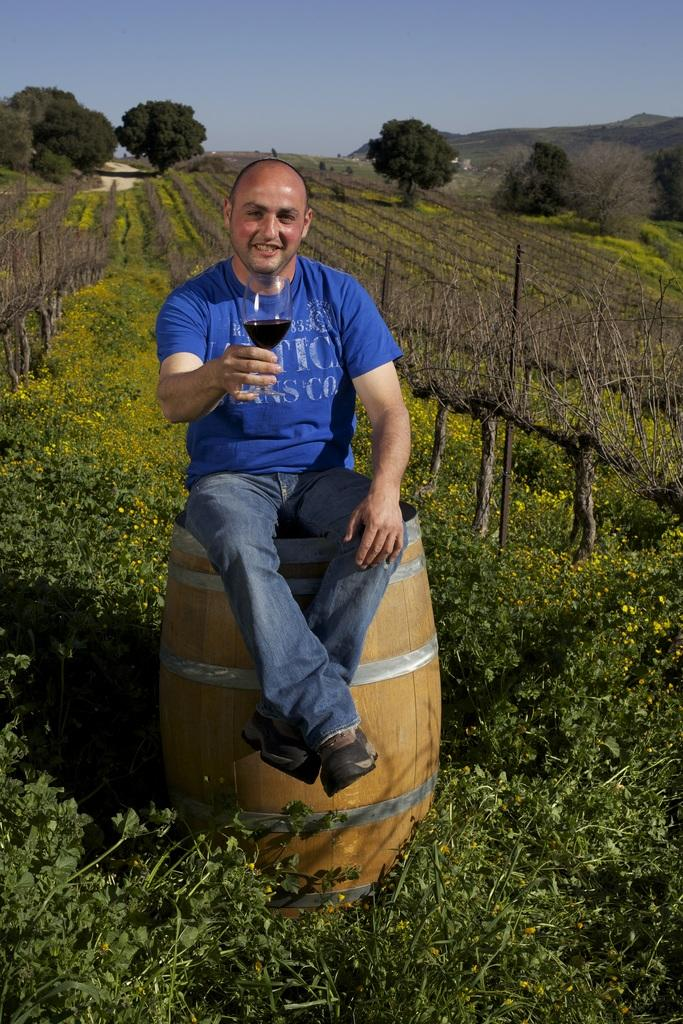What is the man in the image sitting on? The man is sitting on a drum in the image. What object is the man holding in the image? The man is holding a glass in the image. Where does the scene take place? The scene takes place in a garden. What can be seen in the background of the image? Mountains and trees are visible in the background of the image. What type of jeans is the man wearing in the image? There is no information about the man's jeans in the image, as the focus is on the man sitting on a drum and holding a glass. 